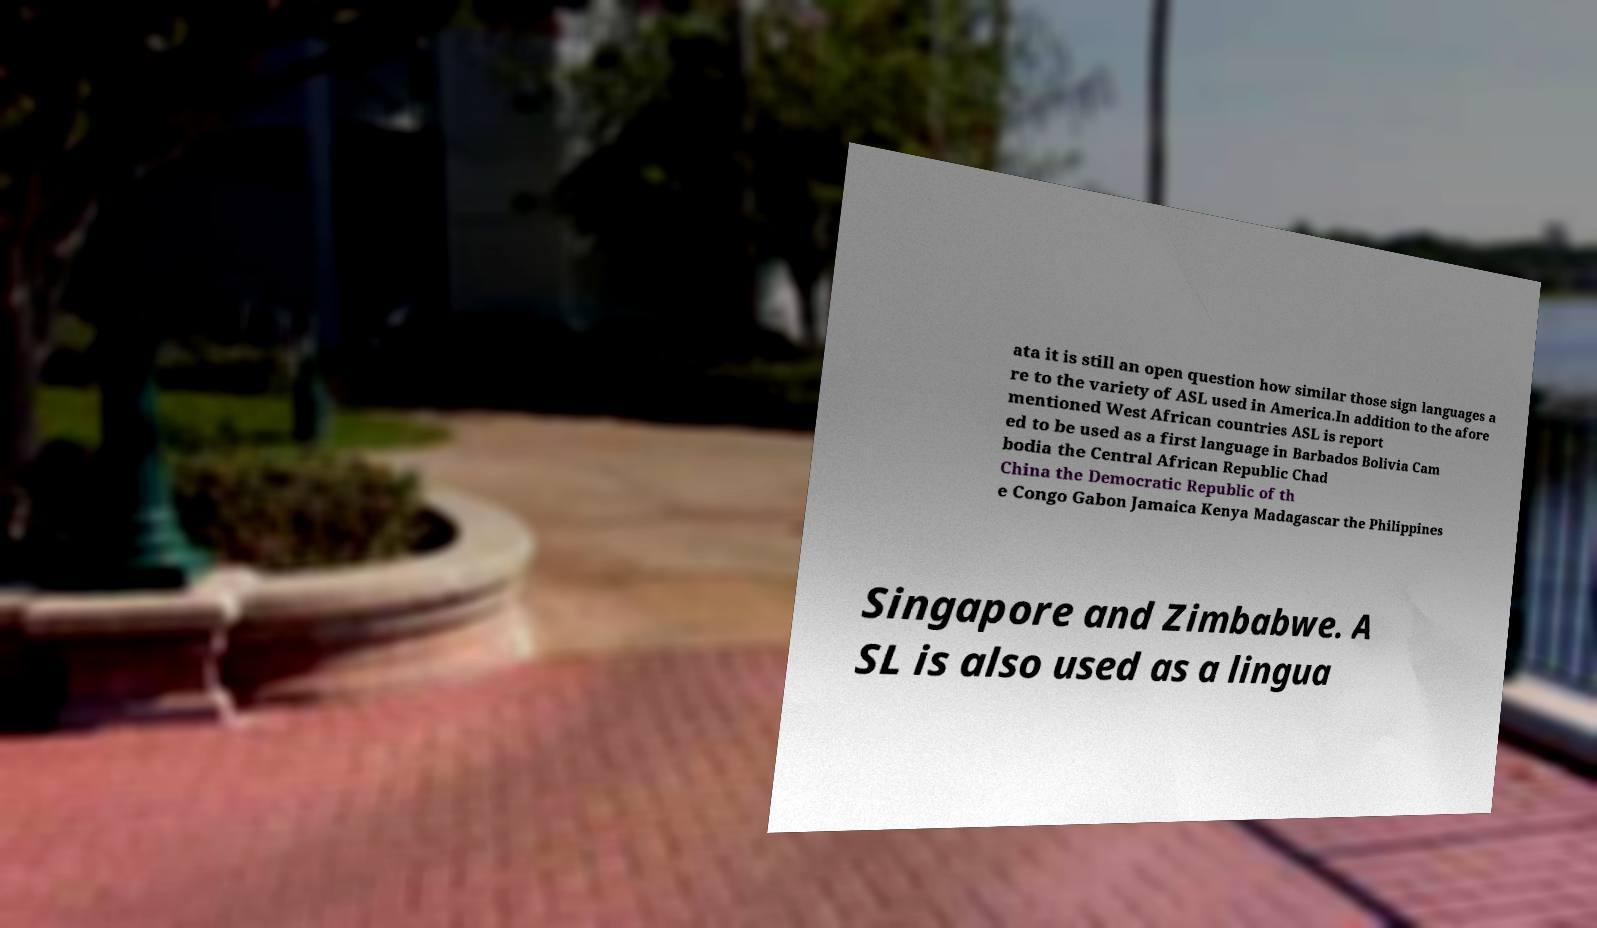Can you read and provide the text displayed in the image?This photo seems to have some interesting text. Can you extract and type it out for me? ata it is still an open question how similar those sign languages a re to the variety of ASL used in America.In addition to the afore mentioned West African countries ASL is report ed to be used as a first language in Barbados Bolivia Cam bodia the Central African Republic Chad China the Democratic Republic of th e Congo Gabon Jamaica Kenya Madagascar the Philippines Singapore and Zimbabwe. A SL is also used as a lingua 